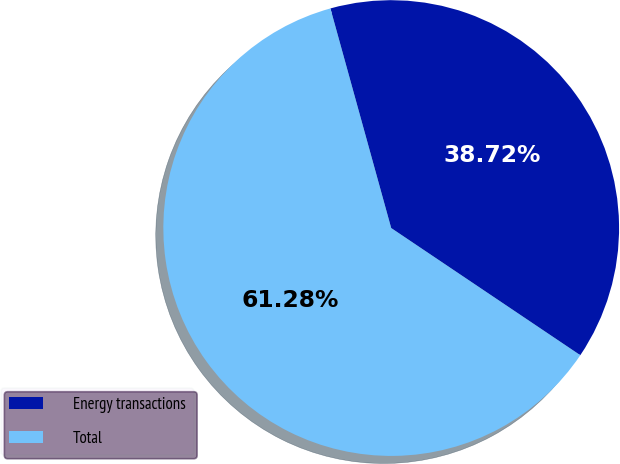Convert chart. <chart><loc_0><loc_0><loc_500><loc_500><pie_chart><fcel>Energy transactions<fcel>Total<nl><fcel>38.72%<fcel>61.28%<nl></chart> 